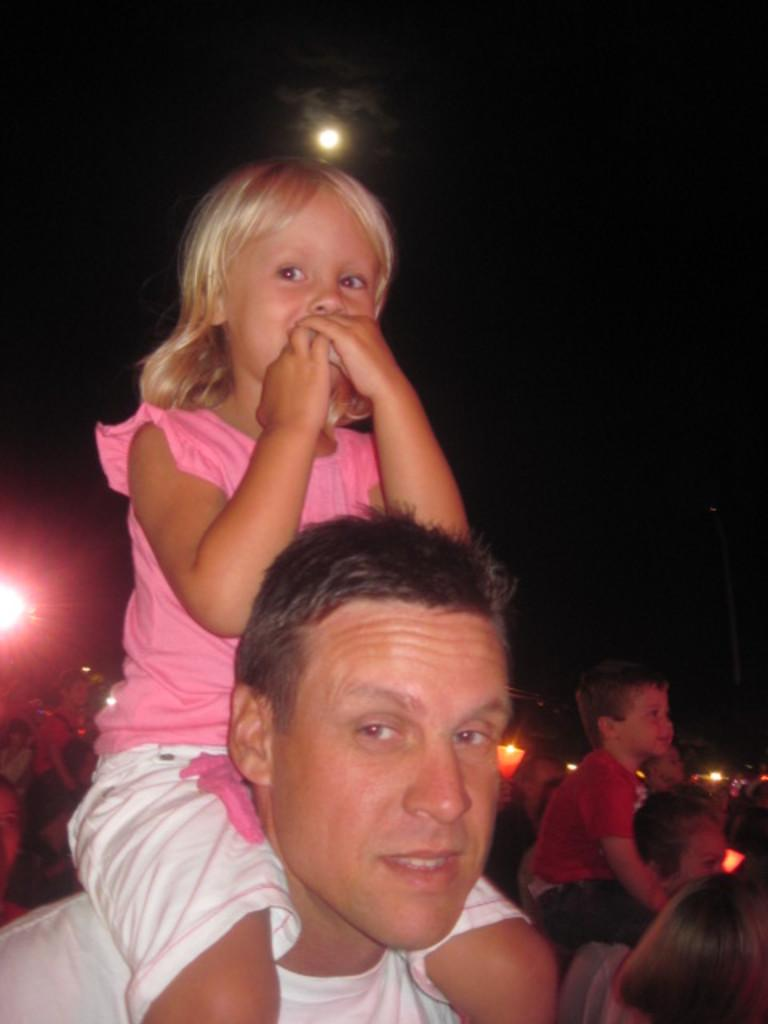How many people are in the group shown in the image? There is a group of people in the image, but the exact number cannot be determined from the provided facts. What are the kids doing in the image? Some kids are sitting on the shoulders of the people in the image. What can be seen behind the people in the image? There are lights visible behind the people in the image. What is visible in the sky in the image? There is a moon in the sky in the image. What type of kite is being flown by the people in the image? There is no kite present in the image; it features a group of people with kids sitting on their shoulders. What song is being sung by the people in the image? There is no indication in the image that the people are singing a song. 